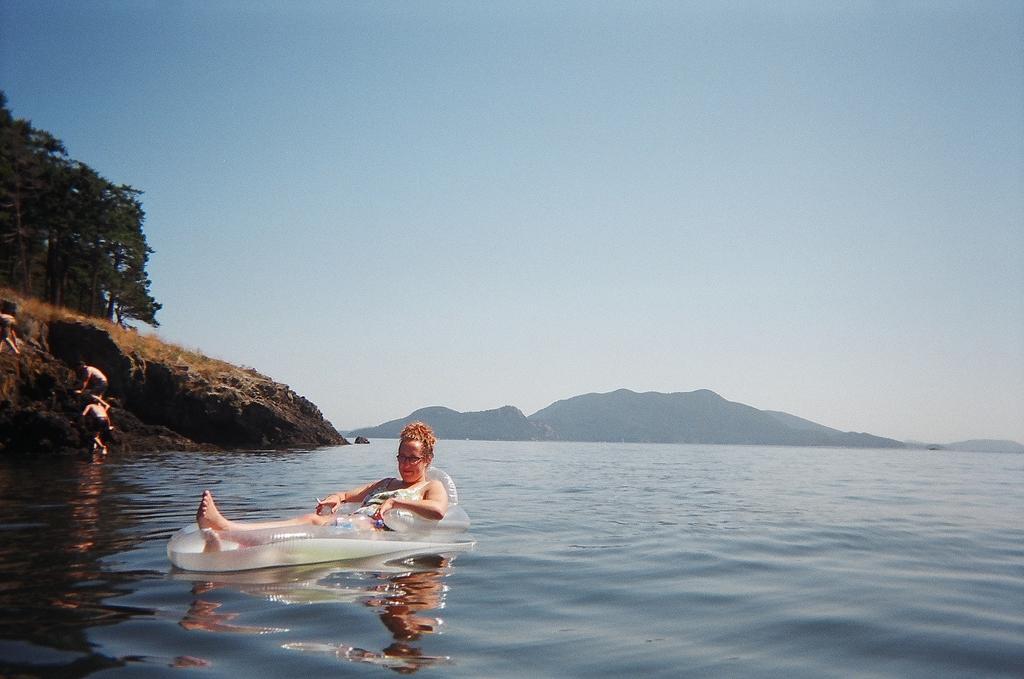Can you describe this image briefly? In this image we can see a woman is sitting on the tube which is floating on the water. Here we can see a few more people climbing the hill, we can see trees, hills and the plain sky in the background. 